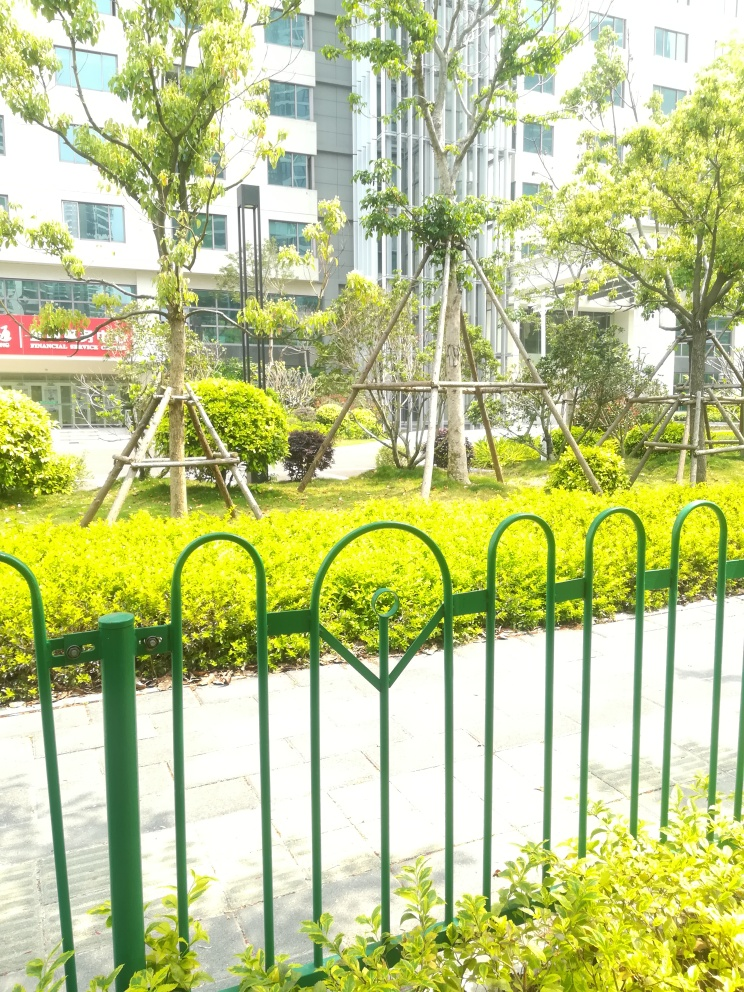Is the subject of the photo clear? Yes, the subject of the photograph is clear. The image depicts a tranquil urban garden scene with a foreground of vibrant green foliage, steady young trees supported by wooden stakes, and a well-maintained grass lawn. Behind this peaceful green area, a modern building with visible windows lines the background, all encapsulated by a medium-height green fence featuring decorative elements. 